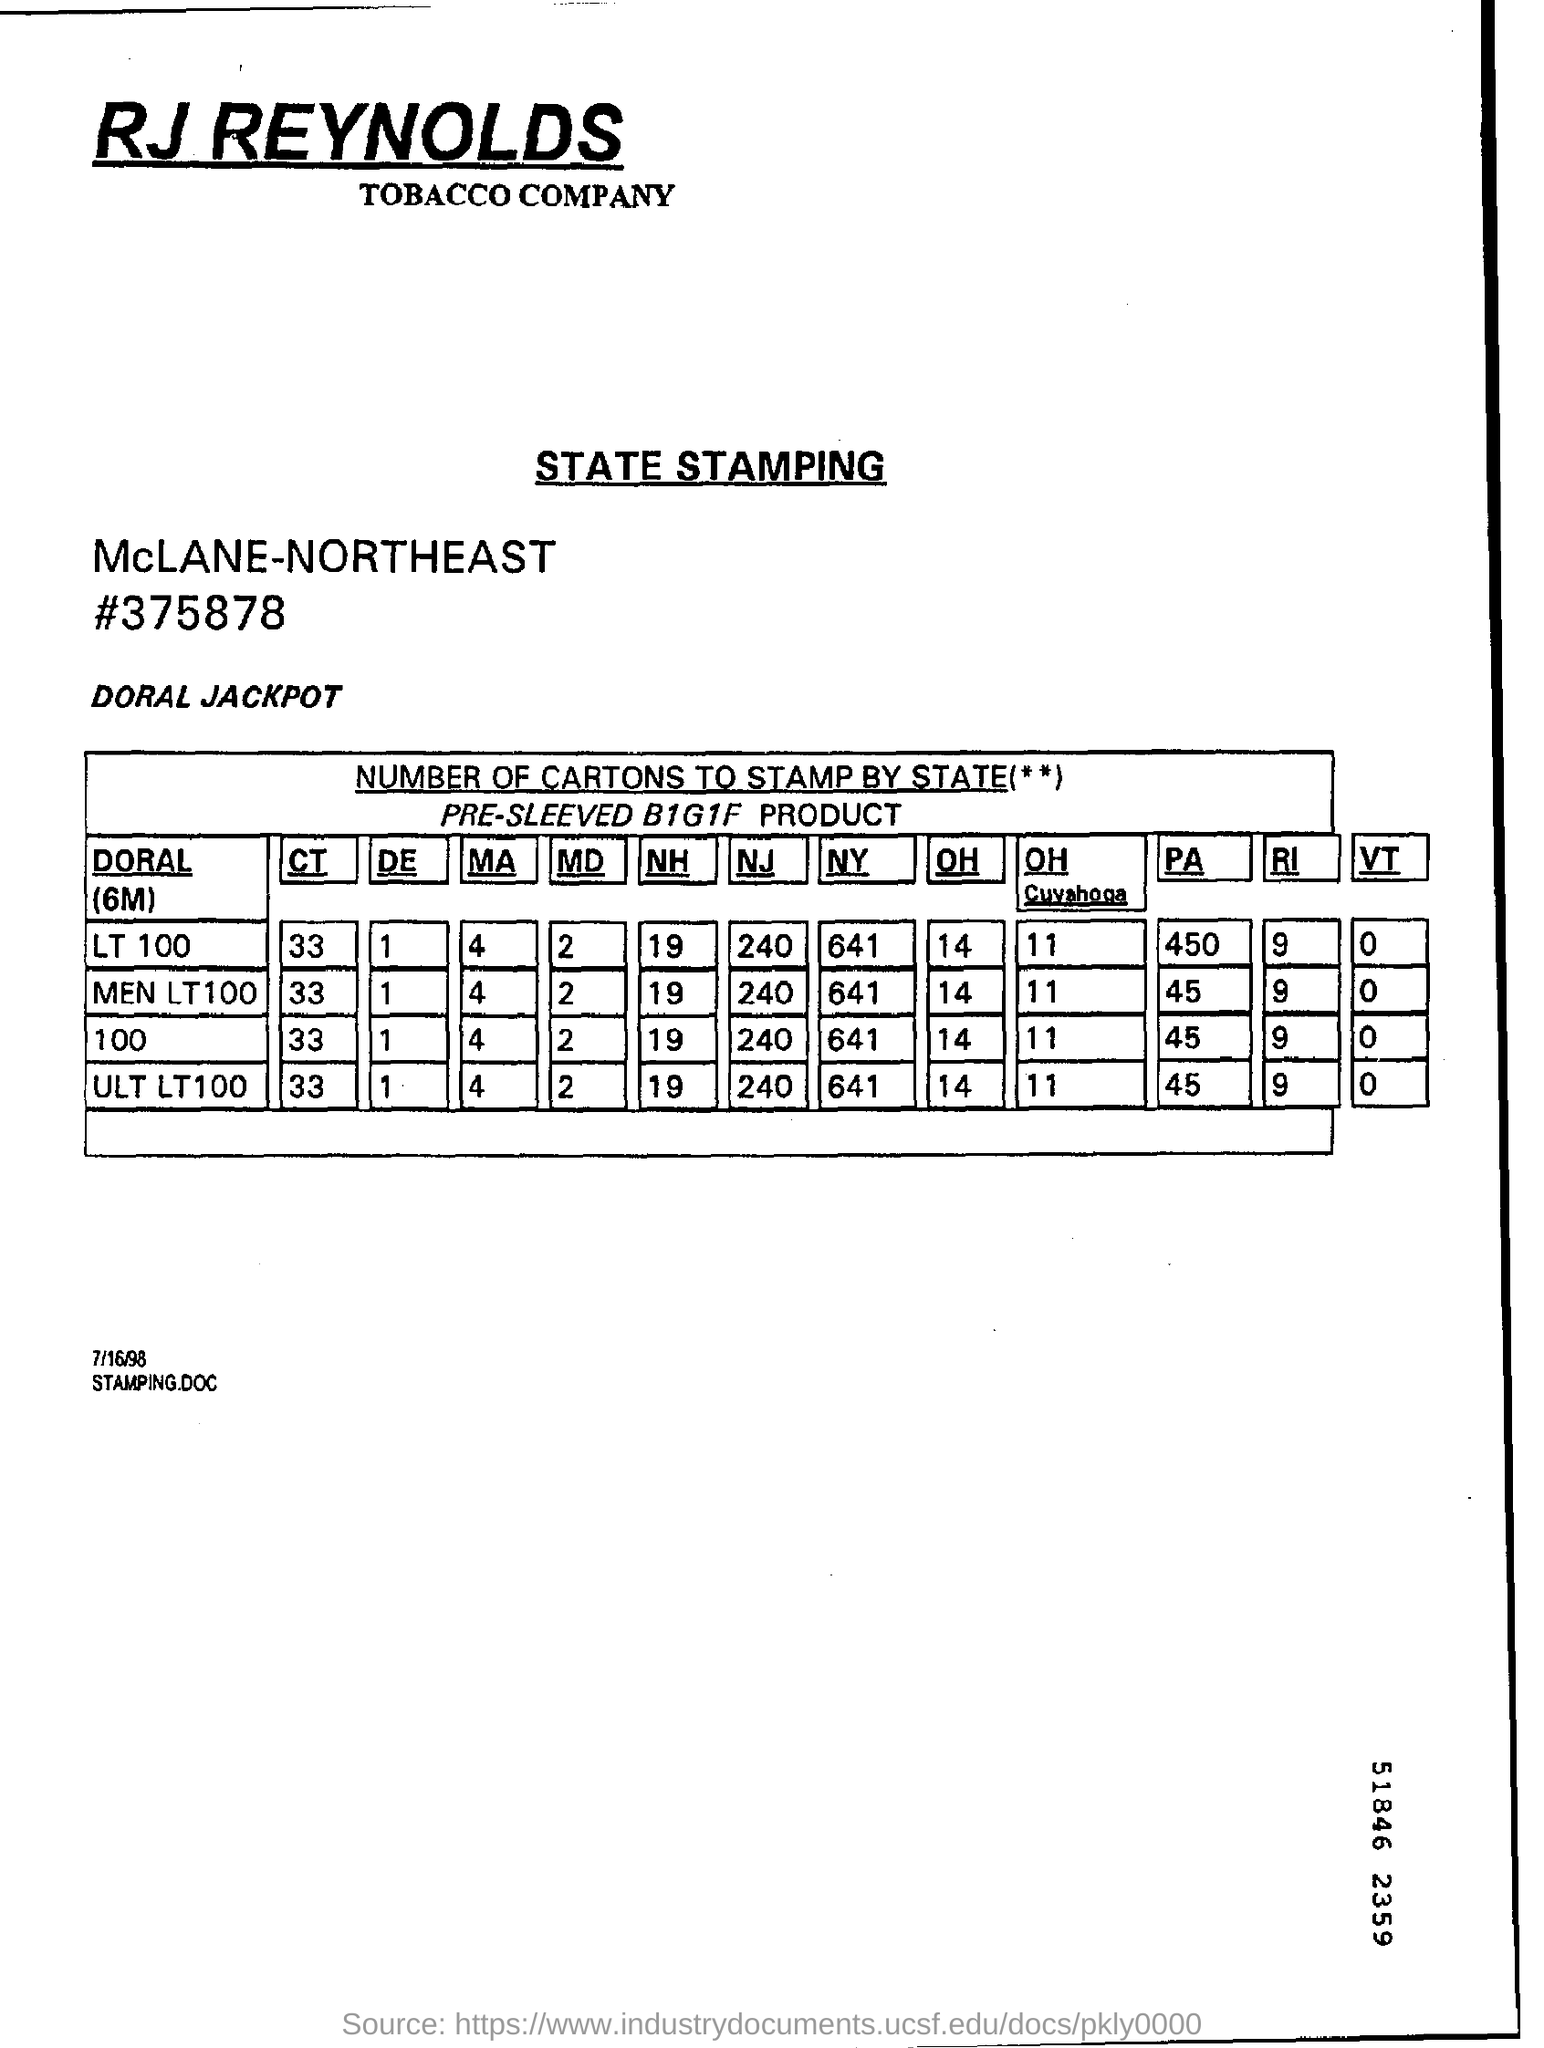What is the name of the tobacco company?
Offer a terse response. RJ REYNOLDS. How many LT 100 cartons are to stamp in NY?
Give a very brief answer. 641. How many ULT LT 100 are to stamp in MA?
Offer a very short reply. 4. What is the serial number on the state stamping document?
Your response must be concise. #375878. 